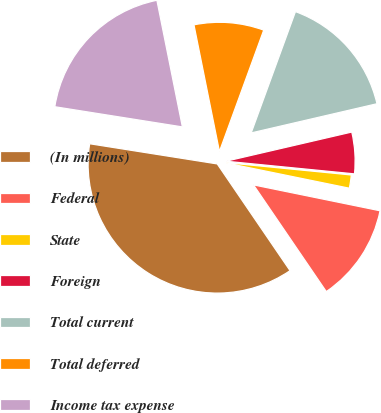<chart> <loc_0><loc_0><loc_500><loc_500><pie_chart><fcel>(In millions)<fcel>Federal<fcel>State<fcel>Foreign<fcel>Total current<fcel>Total deferred<fcel>Income tax expense<nl><fcel>37.02%<fcel>12.26%<fcel>1.65%<fcel>5.19%<fcel>15.8%<fcel>8.73%<fcel>19.34%<nl></chart> 